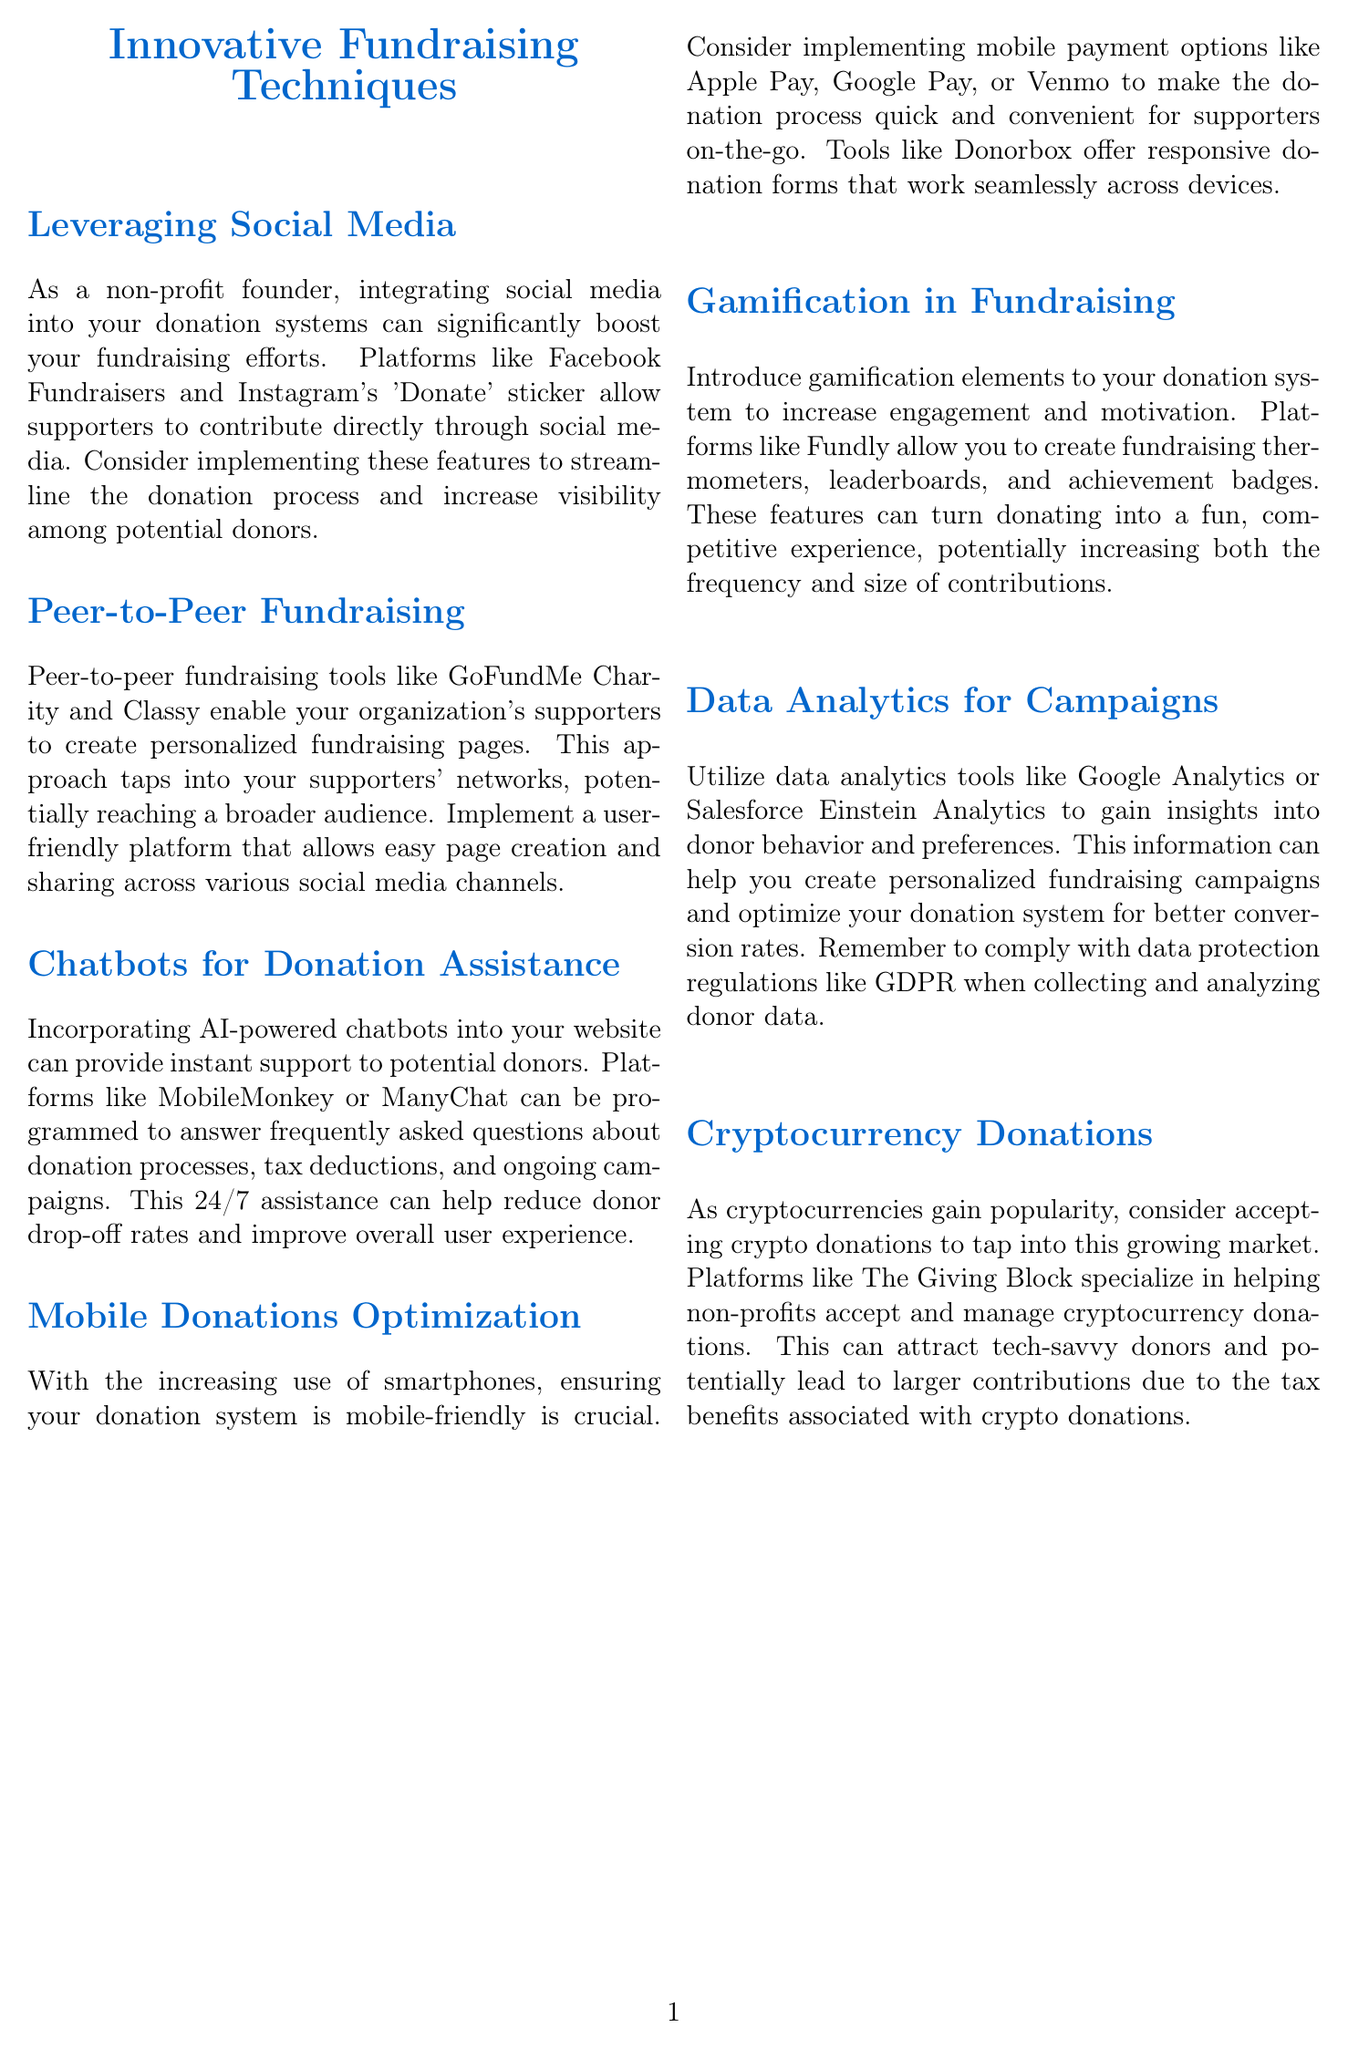What social media platforms are mentioned for fundraising? The document mentions Facebook Fundraisers and Instagram's 'Donate' sticker as platforms for fundraising.
Answer: Facebook Fundraisers, Instagram's 'Donate' sticker What is a tool mentioned for peer-to-peer fundraising? The document specifies GoFundMe Charity and Classy as tools for peer-to-peer fundraising.
Answer: GoFundMe Charity, Classy What mobile payment options are suggested? The newsletter suggests mobile payment options like Apple Pay, Google Pay, or Venmo for donations.
Answer: Apple Pay, Google Pay, Venmo What is the main benefit of integrating chatbots? The document states that chatbots provide instant support to potential donors, reducing donor drop-off rates.
Answer: Instant support, reducing donor drop-off Name one platform used for gamification in fundraising. Fundly is mentioned in the document as a platform to create gamification elements for fundraising.
Answer: Fundly What does integrating cryptocurrency donations aim to attract? The newsletter mentions that accepting cryptocurrency donations aims to attract tech-savvy donors.
Answer: Tech-savvy donors Which data analytics tools are recommended? The document recommends tools like Google Analytics or Salesforce Einstein Analytics for data analytics.
Answer: Google Analytics, Salesforce Einstein Analytics What should be considered when collecting donor data? The document emphasizes compliance with data protection regulations like GDPR when collecting donor data.
Answer: GDPR 